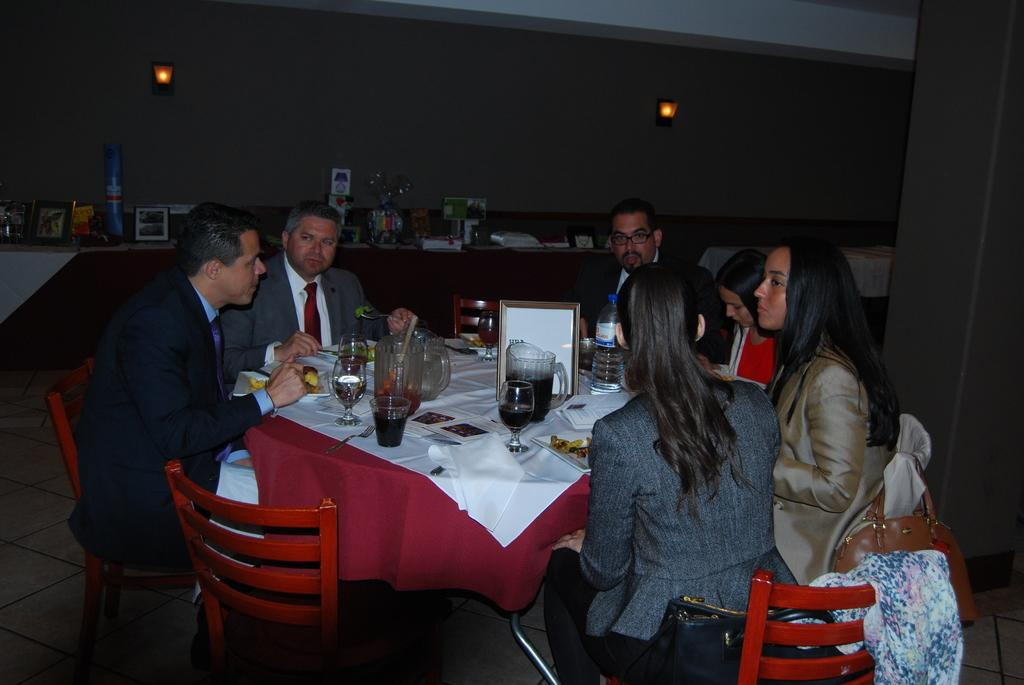What is the main subject of the image? The main subject of the image is a group of people. What are the people doing in the image? The people are sitting in front of a table. What are the people sitting on? The people are sitting on chairs. What type of beverages can be seen on the table? There are soft drinks in glasses and a bottle of water present on the table. What type of punishment is being given to the achiever in the image? There is no mention of punishment or an achiever in the image; it simply shows a group of people sitting in front of a table with beverages. 